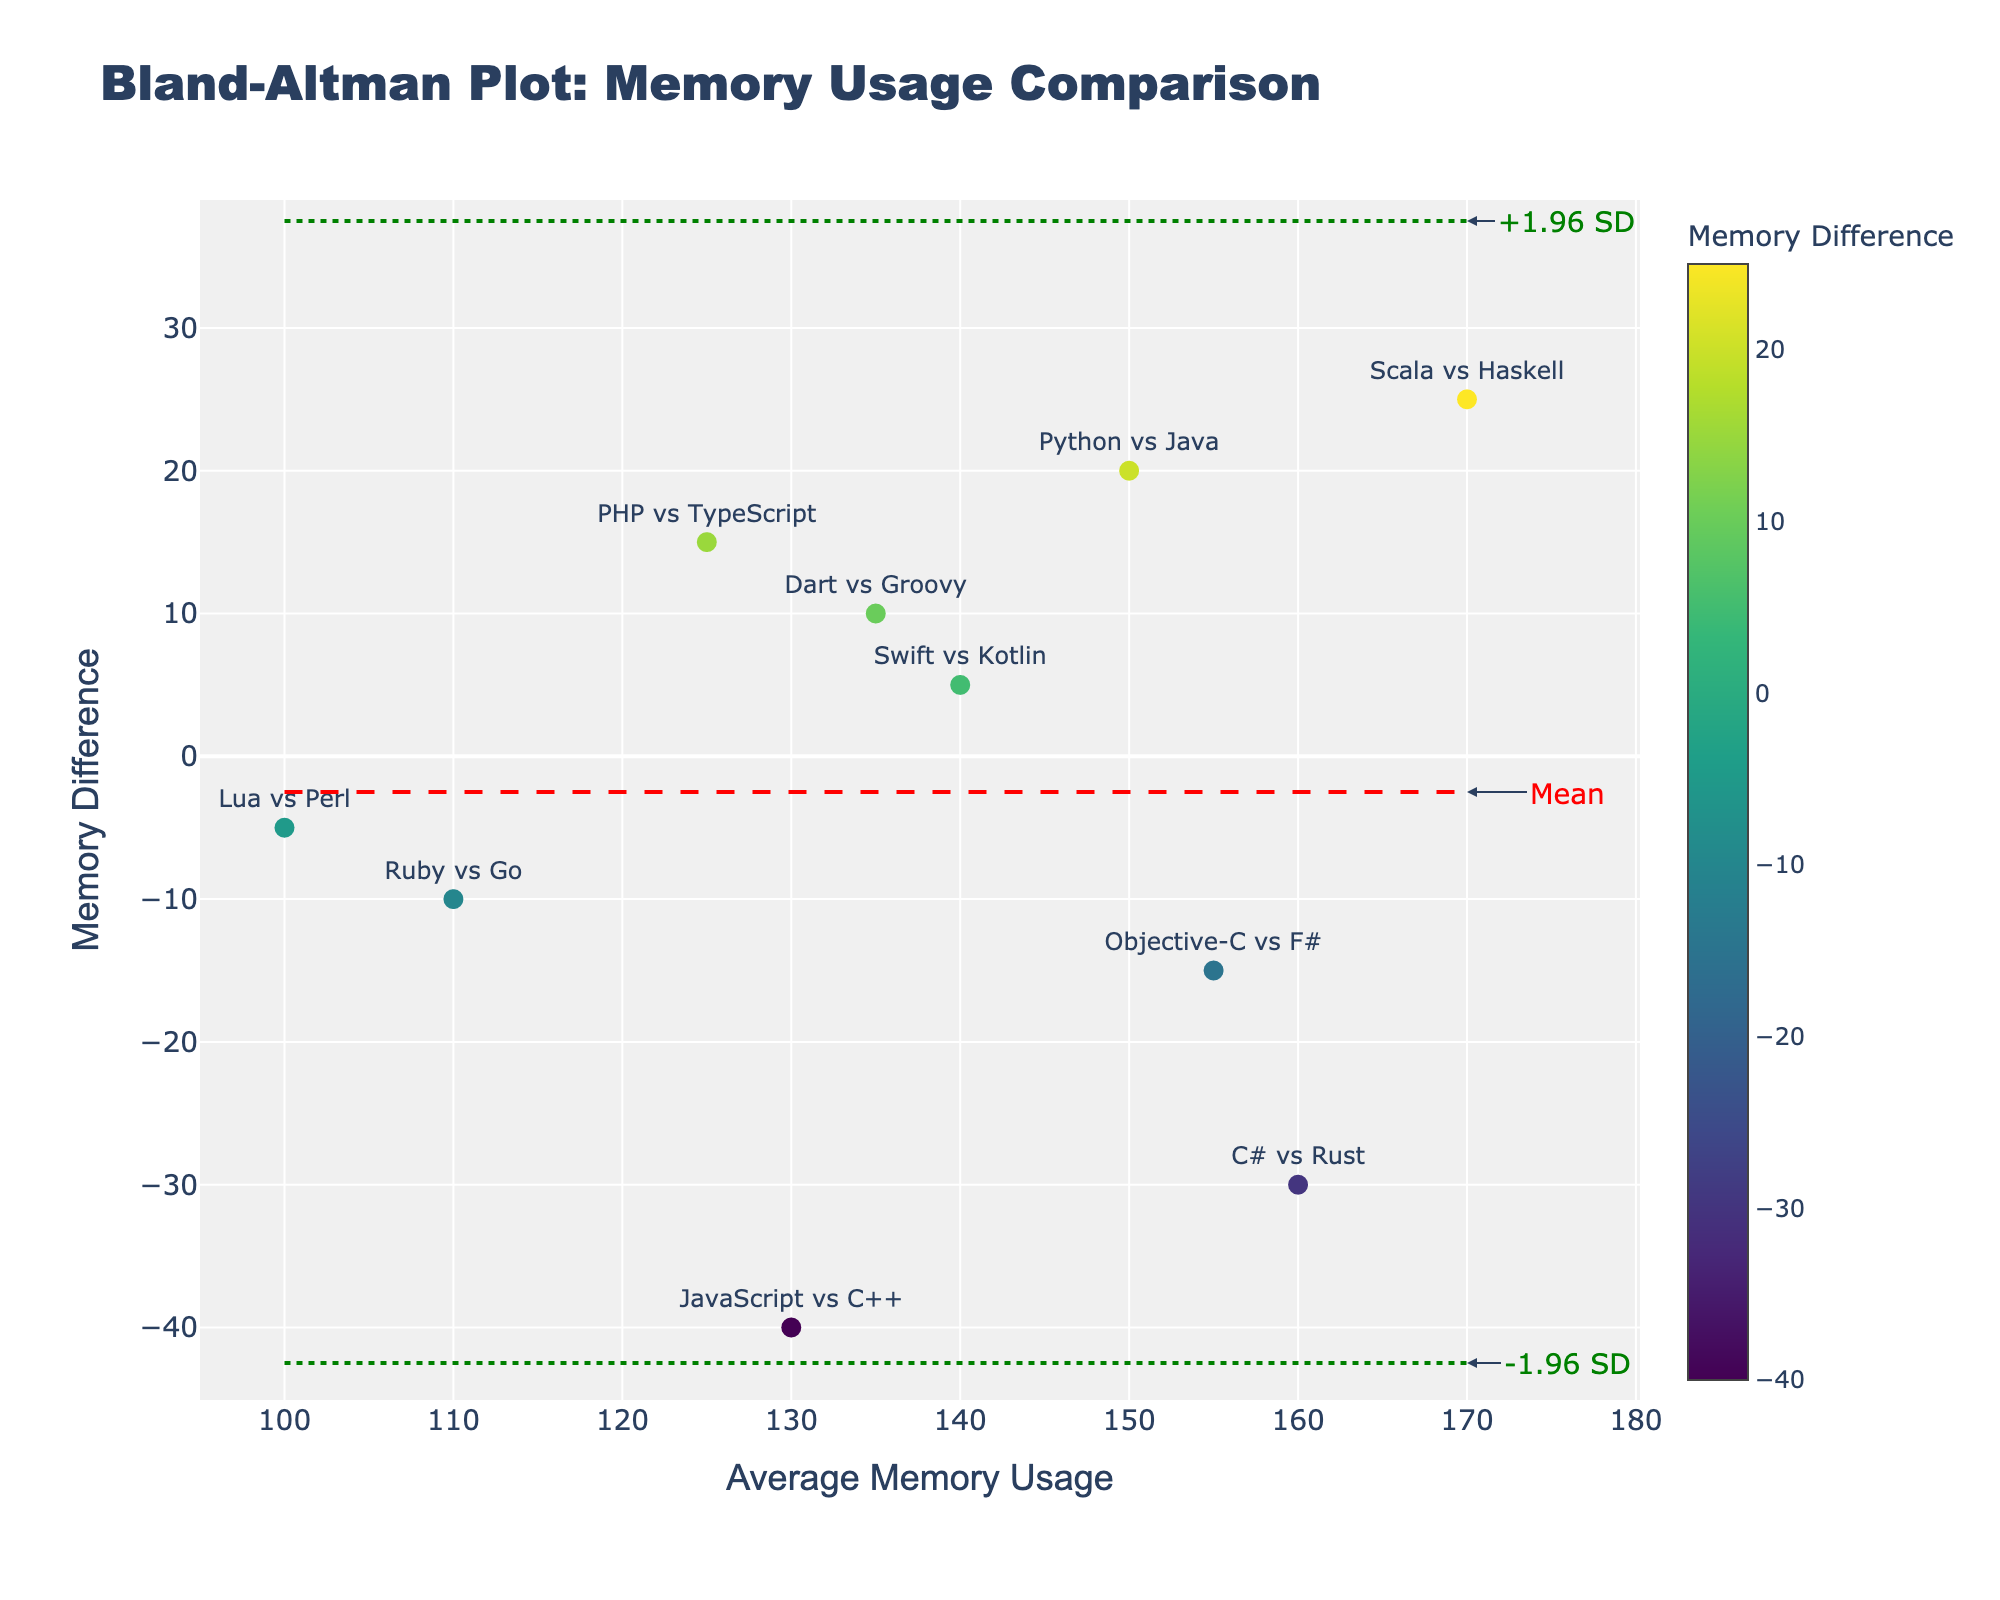What is the title of the plot? The title is displayed at the top of the plot in large, bold font. It gives a summary of what the plot represents.
Answer: Bland-Altman Plot: Memory Usage Comparison What does the y-axis represent? The label of the y-axis indicates the quantity being measured along this axis. It is stated on the y-axis.
Answer: Memory Difference How many programming language pairs are compared in this plot? Each data point represents a comparison between pairs of programming languages. By counting these data points in the plot, you can determine the total number of pairs compared.
Answer: 10 Which pair has the highest average memory usage? By looking at the x-axis and identifying the point furthest to the right, you can determine which pair has the highest average memory usage.
Answer: Scala vs Haskell Which language pair has the largest negative memory difference? Look at the data point that is lowest on the y-axis to identify which language pair has the largest negative memory difference. This value is the most negative (farthest below the x-axis).
Answer: JavaScript vs C++ What is the average memory usage and memory difference for Python vs Java? Locate the data point for Python vs Java and reference the hover text or labels to find the average memory usage and memory difference for this pair.
Answer: Average Memory: 150, Memory Difference: 20 How is the mean difference visually represented in the plot? The mean difference is usually shown as a horizontal line across the plot. Identify this line and any annotations or colors associated with it.
Answer: A red dashed line What do the green dotted lines represent in this plot? The green dotted lines typically represent the limits of agreement, which are often set at ±1.96 standard deviations from the mean difference. Look for annotations or hover text that confirm this.
Answer: ±1.96 SD Which pairs fall outside the limits of agreement (green dotted lines)? Identify any data points that lie above or below the green dotted lines, as these indicate pairs that fall outside the limits of agreement.
Answer: JavaScript vs C++, Scala vs Haskell 